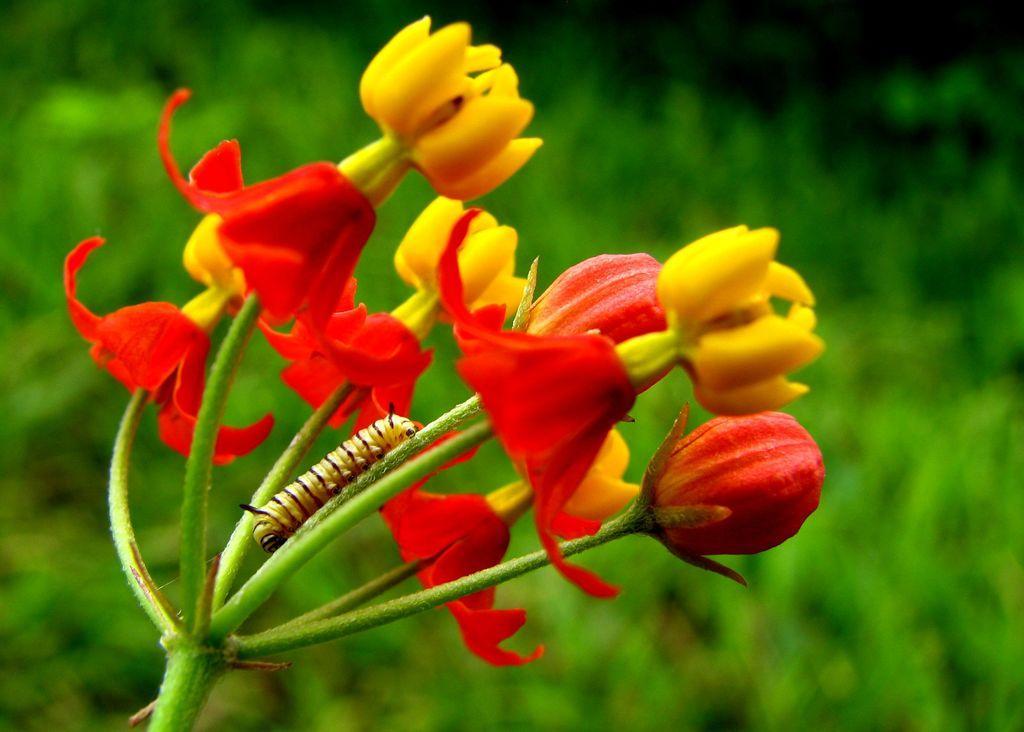In one or two sentences, can you explain what this image depicts? In this picture there is an insect on the plant and there are red and yellow color flowers on the plant. At the back there are plants. 